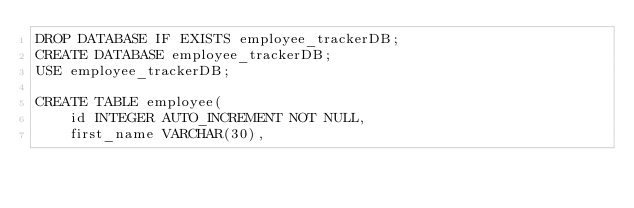<code> <loc_0><loc_0><loc_500><loc_500><_SQL_>DROP DATABASE IF EXISTS employee_trackerDB;
CREATE DATABASE employee_trackerDB;
USE employee_trackerDB;

CREATE TABLE employee(
    id INTEGER AUTO_INCREMENT NOT NULL,
    first_name VARCHAR(30),</code> 